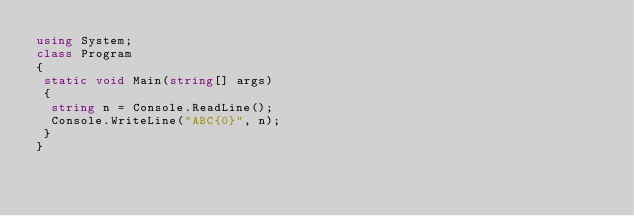<code> <loc_0><loc_0><loc_500><loc_500><_C#_>using System;
class Program
{
 static void Main(string[] args)
 {
  string n = Console.ReadLine();
  Console.WriteLine("ABC{0}", n);
 }
}
</code> 